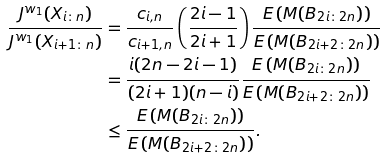<formula> <loc_0><loc_0><loc_500><loc_500>\frac { J ^ { w _ { 1 } } ( X _ { i \colon n } ) } { J ^ { w _ { 1 } } ( X _ { i + 1 \colon n } ) } & = \frac { c _ { i , n } } { c _ { i + 1 , n } } \left ( \frac { 2 i - 1 } { 2 i + 1 } \right ) \frac { E \left ( M ( B _ { 2 i \colon 2 n } ) \right ) } { E \left ( M ( B _ { 2 i + 2 \colon 2 n } ) \right ) } \\ & = \frac { i ( 2 n - 2 i - 1 ) } { ( 2 i + 1 ) ( n - i ) } \frac { E \left ( M ( B _ { 2 i \colon 2 n } ) \right ) } { E \left ( M ( B _ { 2 i + 2 \colon 2 n } ) \right ) } \\ & \leq \frac { E \left ( M ( B _ { 2 i \colon 2 n } ) \right ) } { E \left ( M ( B _ { 2 i + 2 \colon 2 n } ) \right ) } .</formula> 